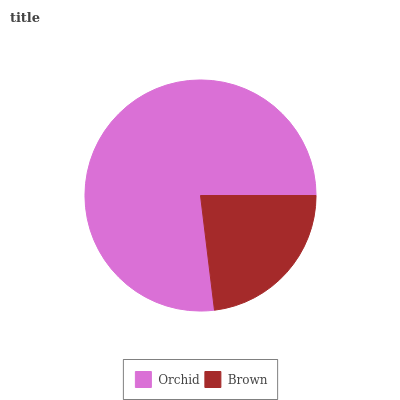Is Brown the minimum?
Answer yes or no. Yes. Is Orchid the maximum?
Answer yes or no. Yes. Is Brown the maximum?
Answer yes or no. No. Is Orchid greater than Brown?
Answer yes or no. Yes. Is Brown less than Orchid?
Answer yes or no. Yes. Is Brown greater than Orchid?
Answer yes or no. No. Is Orchid less than Brown?
Answer yes or no. No. Is Orchid the high median?
Answer yes or no. Yes. Is Brown the low median?
Answer yes or no. Yes. Is Brown the high median?
Answer yes or no. No. Is Orchid the low median?
Answer yes or no. No. 